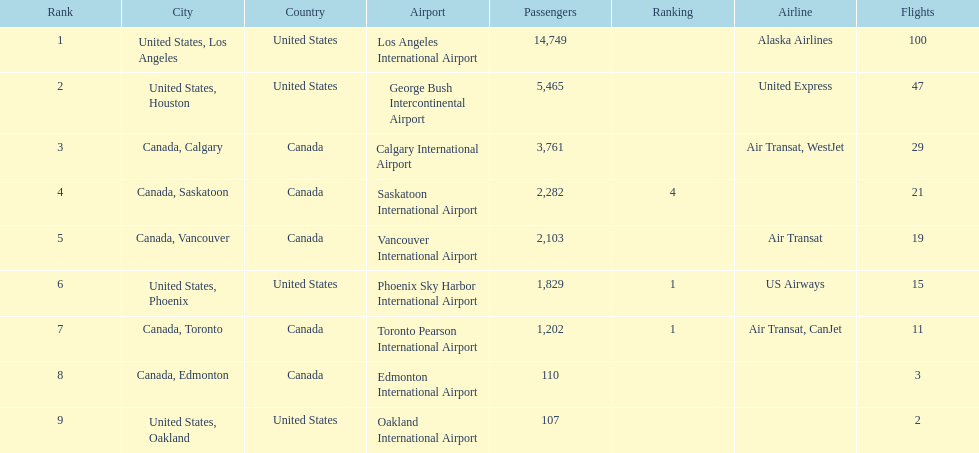How many airlines have a steady ranking? 4. 